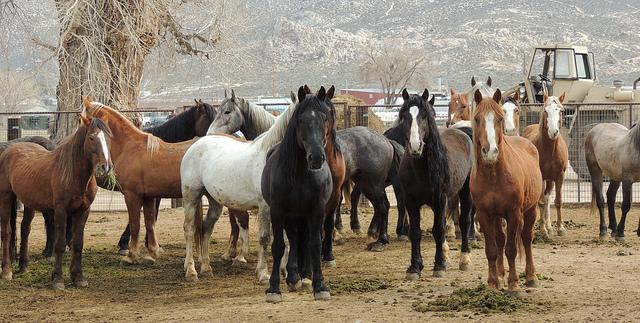What is the name of the fenced off area for these horses? Please explain your reasoning. corral. This is just what it's called. 